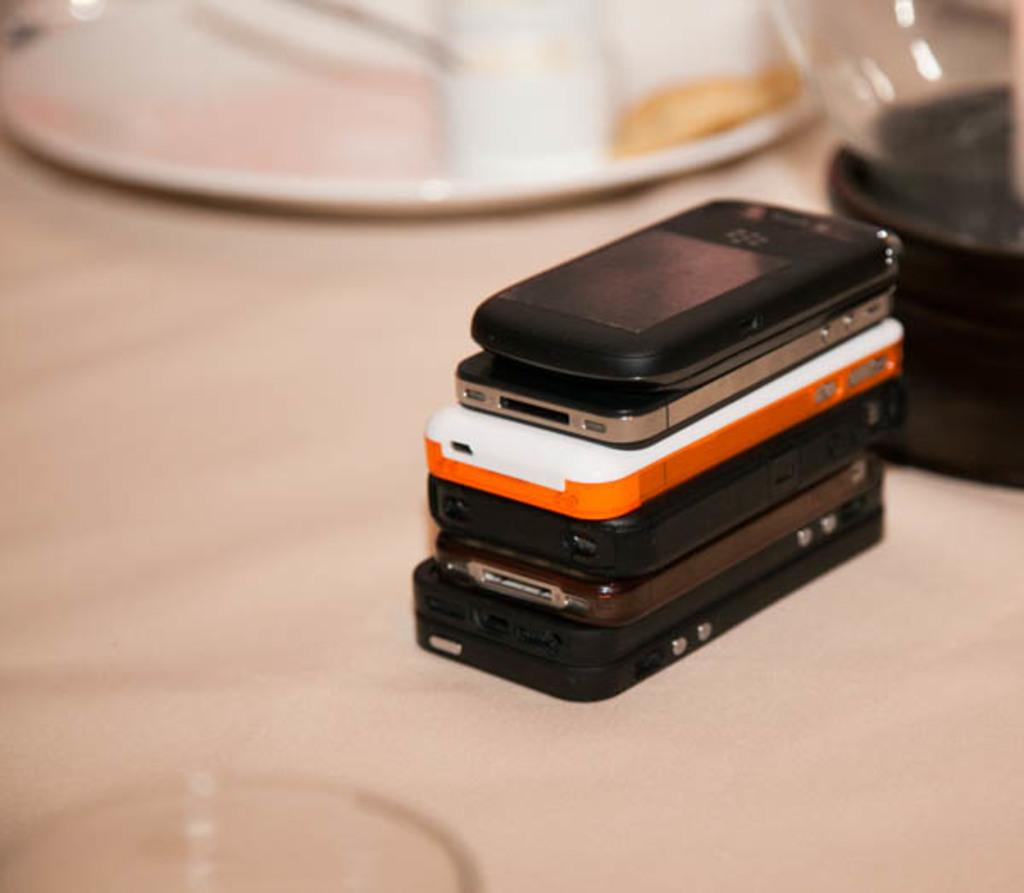What objects are on the table in the image? There are mobiles and a plate on the table. Can you describe any other items on the table? There are other unspecified things on the table. How many children are playing with the mobiles in the image? There are no children present in the image; it only shows mobiles and a plate on the table. 